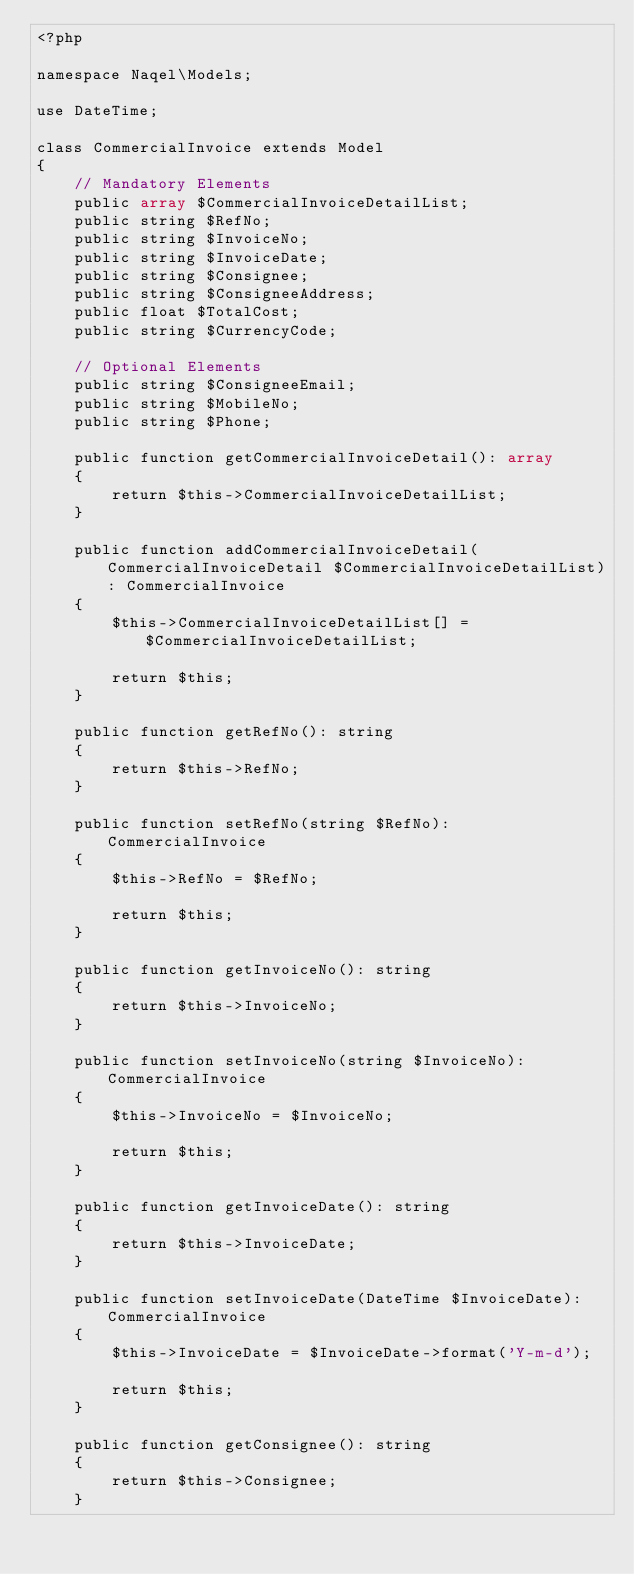Convert code to text. <code><loc_0><loc_0><loc_500><loc_500><_PHP_><?php

namespace Naqel\Models;

use DateTime;

class CommercialInvoice extends Model
{
    // Mandatory Elements
    public array $CommercialInvoiceDetailList;
    public string $RefNo;
    public string $InvoiceNo;
    public string $InvoiceDate;
    public string $Consignee;
    public string $ConsigneeAddress;
    public float $TotalCost;
    public string $CurrencyCode;

    // Optional Elements
    public string $ConsigneeEmail;
    public string $MobileNo;
    public string $Phone;

    public function getCommercialInvoiceDetail(): array
    {
        return $this->CommercialInvoiceDetailList;
    }

    public function addCommercialInvoiceDetail(CommercialInvoiceDetail $CommercialInvoiceDetailList): CommercialInvoice
    {
        $this->CommercialInvoiceDetailList[] = $CommercialInvoiceDetailList;

        return $this;
    }

    public function getRefNo(): string
    {
        return $this->RefNo;
    }

    public function setRefNo(string $RefNo): CommercialInvoice
    {
        $this->RefNo = $RefNo;

        return $this;
    }

    public function getInvoiceNo(): string
    {
        return $this->InvoiceNo;
    }

    public function setInvoiceNo(string $InvoiceNo): CommercialInvoice
    {
        $this->InvoiceNo = $InvoiceNo;

        return $this;
    }

    public function getInvoiceDate(): string
    {
        return $this->InvoiceDate;
    }

    public function setInvoiceDate(DateTime $InvoiceDate): CommercialInvoice
    {
        $this->InvoiceDate = $InvoiceDate->format('Y-m-d');

        return $this;
    }

    public function getConsignee(): string
    {
        return $this->Consignee;
    }
</code> 